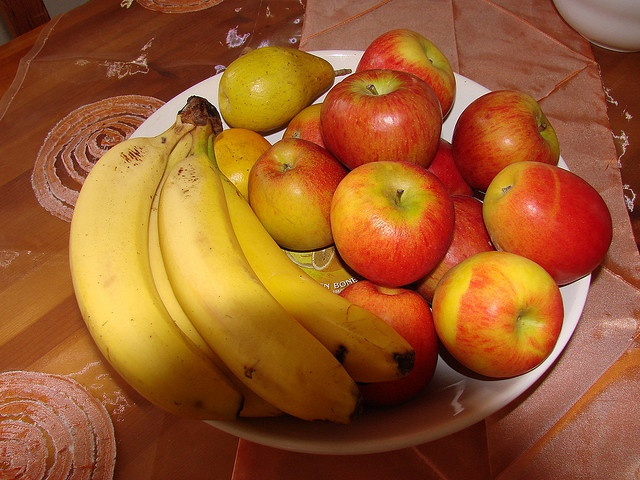Describe the objects in this image and their specific colors. I can see apple in maroon, brown, red, and orange tones, banana in maroon, gold, olive, and orange tones, and bowl in maroon and gray tones in this image. 